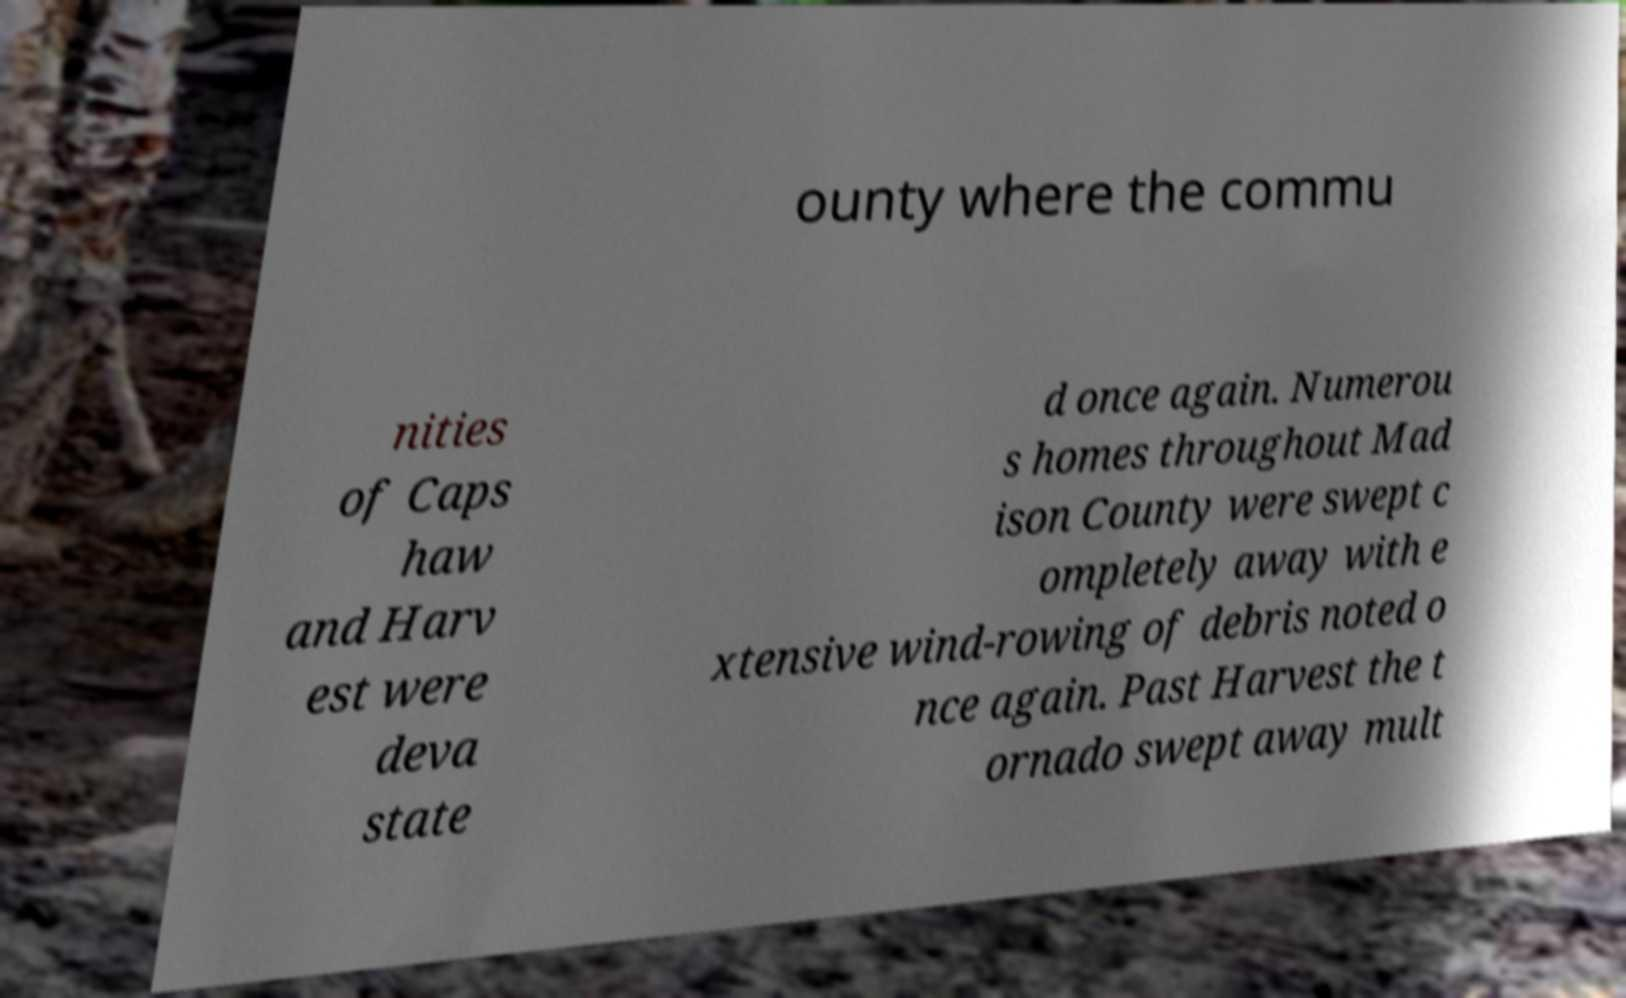Could you assist in decoding the text presented in this image and type it out clearly? ounty where the commu nities of Caps haw and Harv est were deva state d once again. Numerou s homes throughout Mad ison County were swept c ompletely away with e xtensive wind-rowing of debris noted o nce again. Past Harvest the t ornado swept away mult 